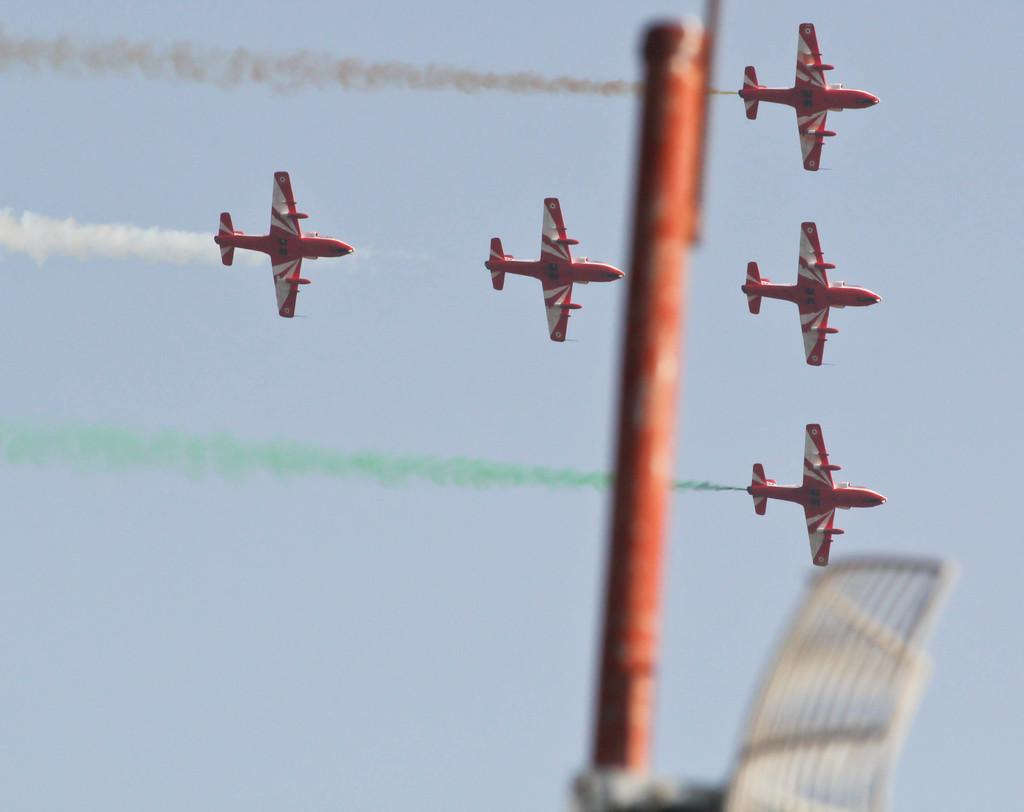What is the color of the pole in the image? The pole in the image is orange-colored. What is located in the front of the image? There is an antenna in the front of the image. How many aircraft can be seen in the background of the image? There are five aircraft in the background of the image. What can be observed in the air in the background? There is smoke in the air in the background. What is visible in the distance in the image? The sky is visible in the background of the image. Where is the plantation located in the image? There is no plantation present in the image. What type of wrench is being used by the aircraft in the image? There are no wrenches visible in the image, and the aircraft are not shown using any tools. 